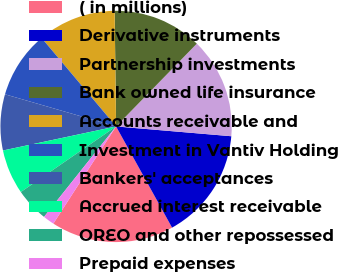Convert chart to OTSL. <chart><loc_0><loc_0><loc_500><loc_500><pie_chart><fcel>( in millions)<fcel>Derivative instruments<fcel>Partnership investments<fcel>Bank owned life insurance<fcel>Accounts receivable and<fcel>Investment in Vantiv Holding<fcel>Bankers' acceptances<fcel>Accrued interest receivable<fcel>OREO and other repossessed<fcel>Prepaid expenses<nl><fcel>17.17%<fcel>15.61%<fcel>14.05%<fcel>12.5%<fcel>10.94%<fcel>9.38%<fcel>7.82%<fcel>6.26%<fcel>4.7%<fcel>1.58%<nl></chart> 